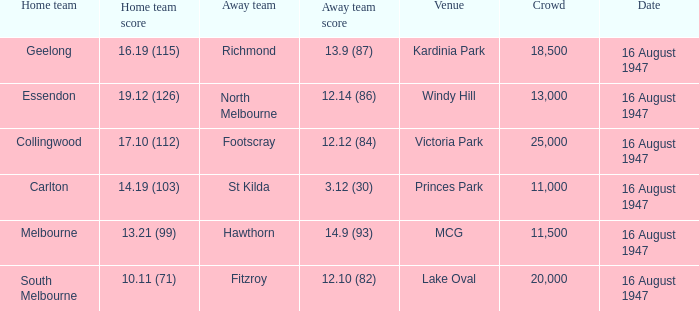What home team has had a crowd bigger than 20,000? Collingwood. 